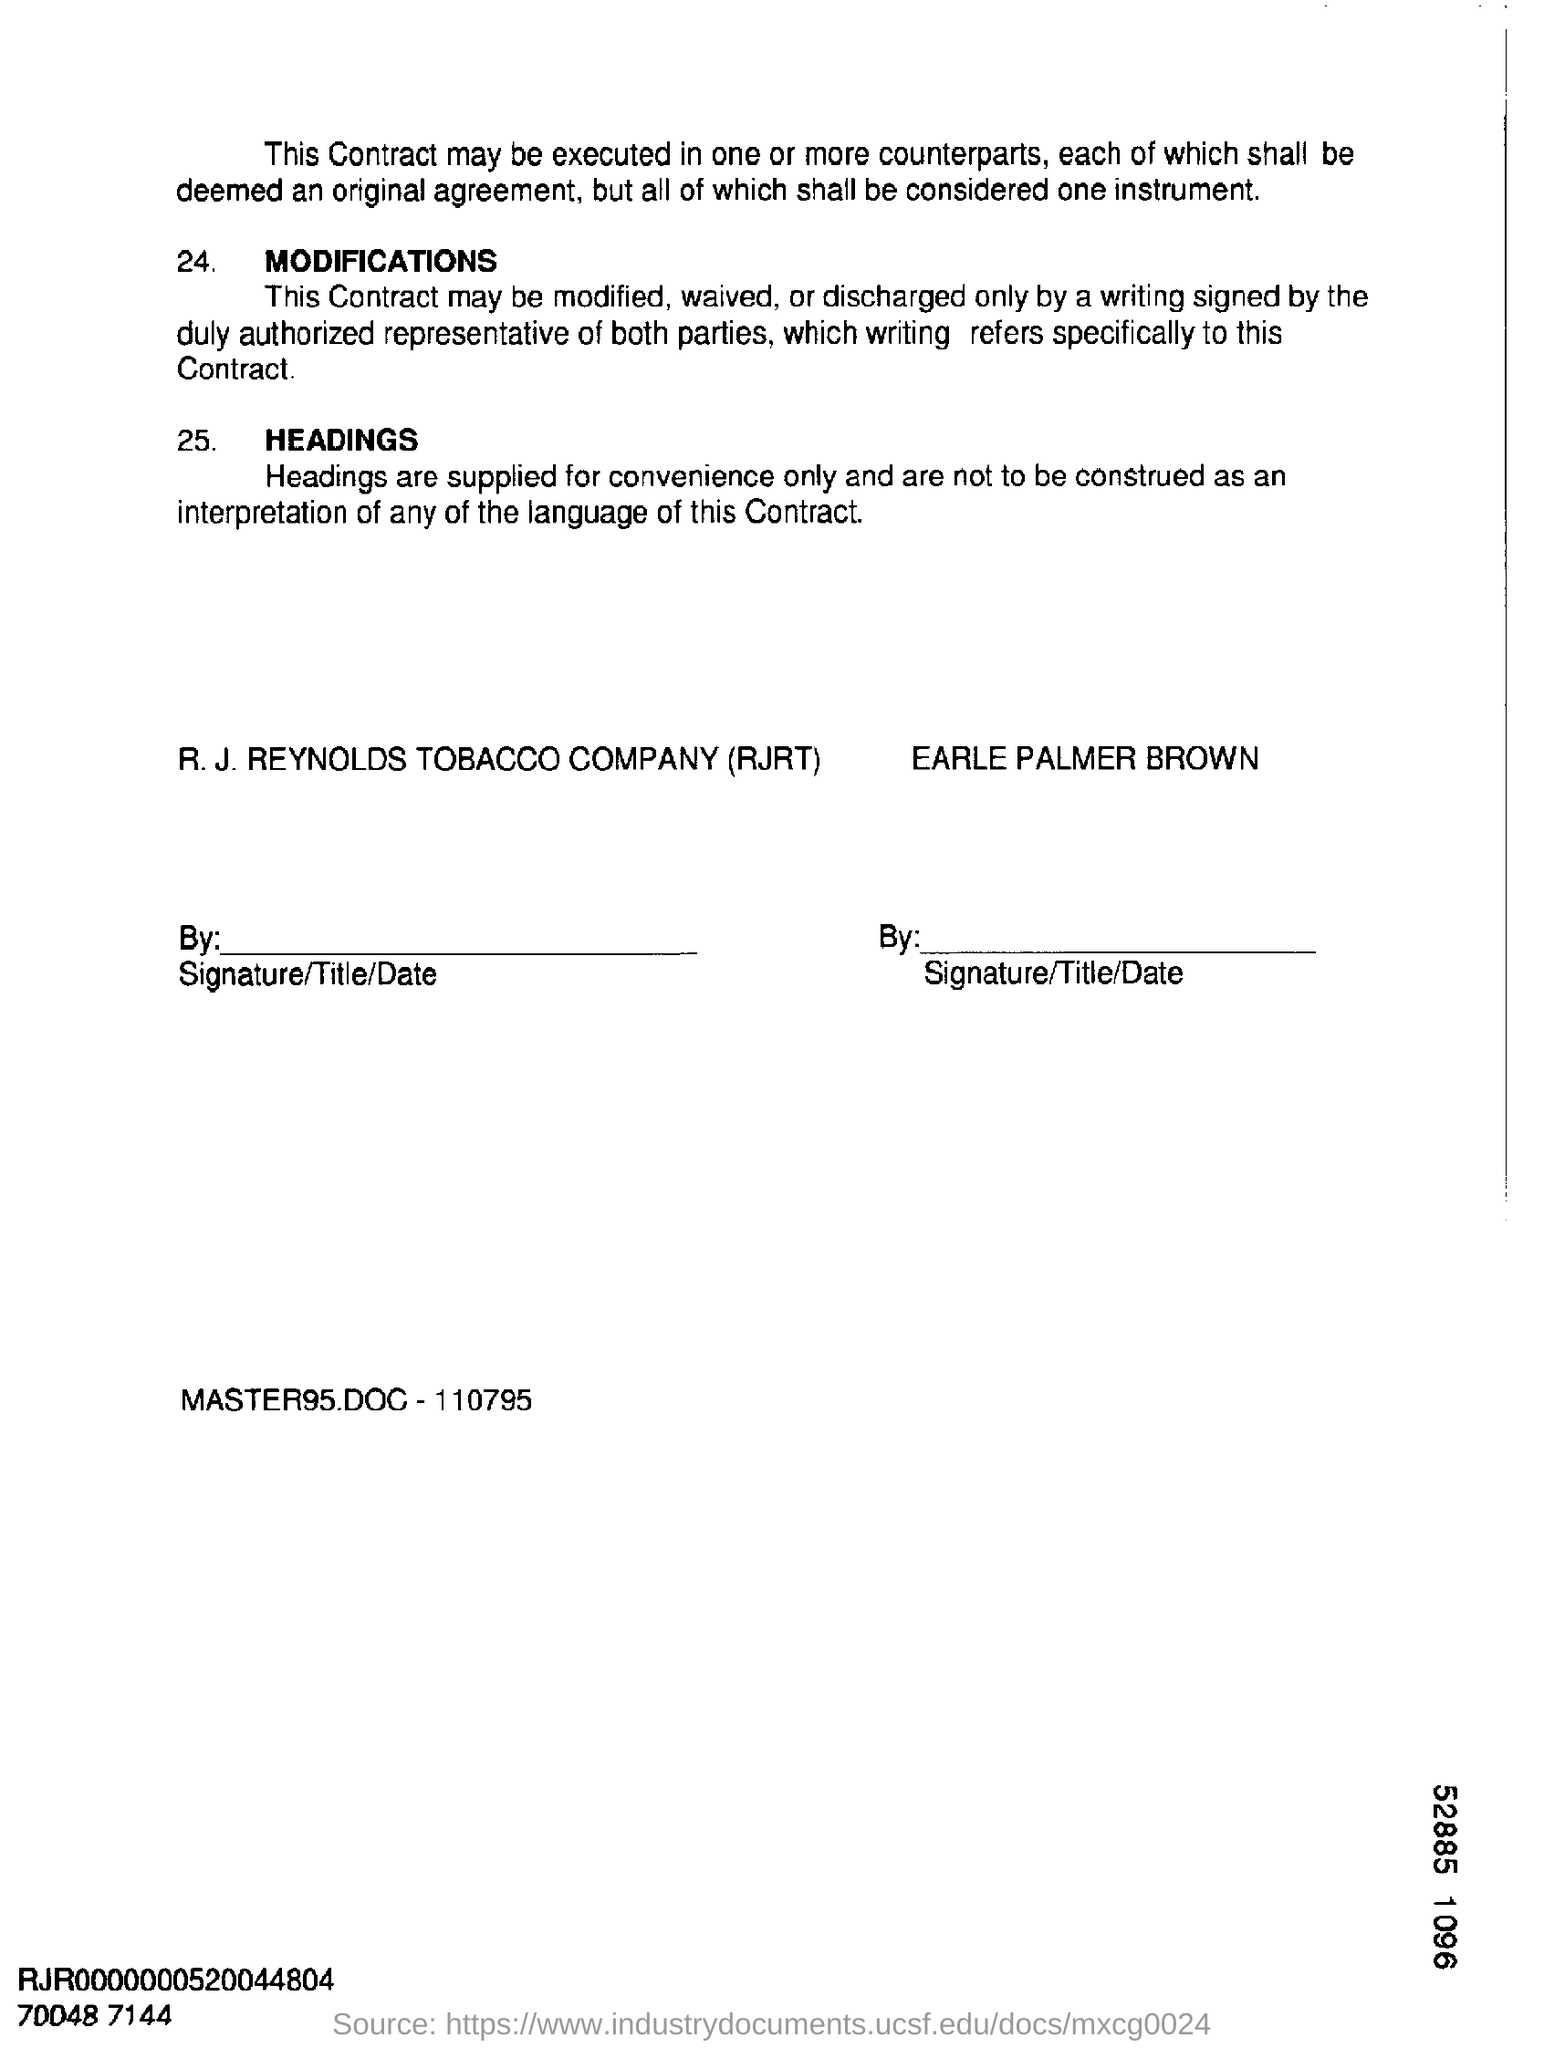Give some essential details in this illustration. RJRT stands for the R.J. Reynolds Tobacco Company. What is the Master95 document number? It is 110795... 